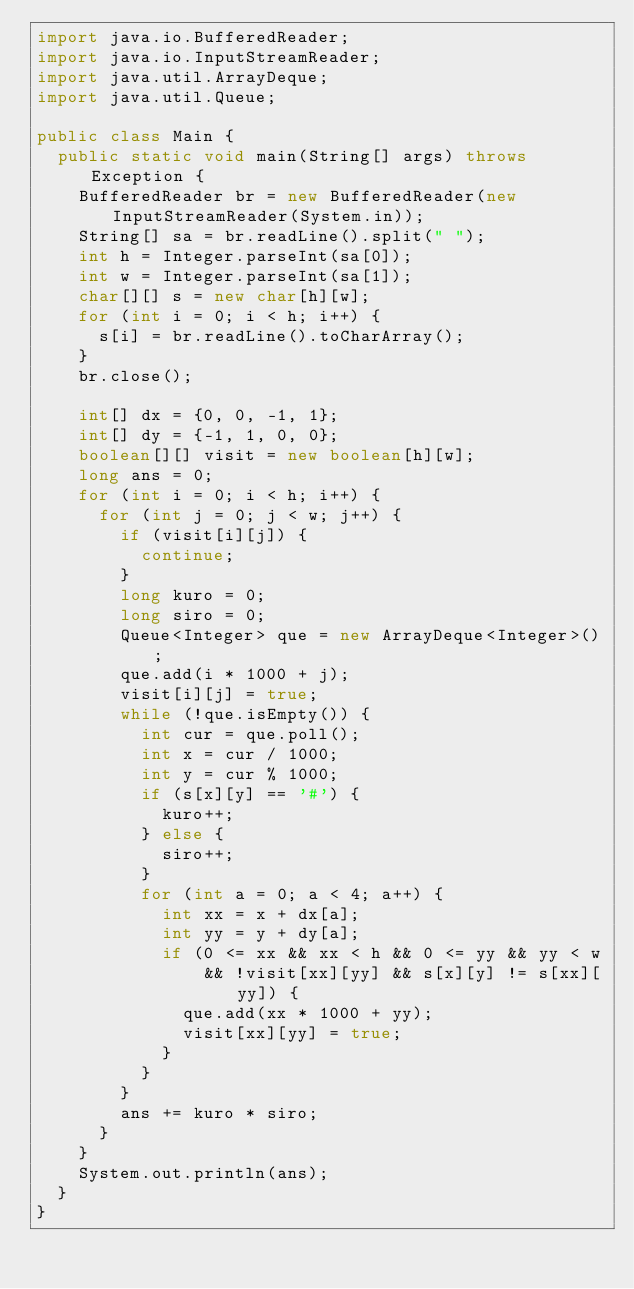<code> <loc_0><loc_0><loc_500><loc_500><_Java_>import java.io.BufferedReader;
import java.io.InputStreamReader;
import java.util.ArrayDeque;
import java.util.Queue;

public class Main {
	public static void main(String[] args) throws Exception {
		BufferedReader br = new BufferedReader(new InputStreamReader(System.in));
		String[] sa = br.readLine().split(" ");
		int h = Integer.parseInt(sa[0]);
		int w = Integer.parseInt(sa[1]);
		char[][] s = new char[h][w];
		for (int i = 0; i < h; i++) {
			s[i] = br.readLine().toCharArray();
		}
		br.close();

		int[] dx = {0, 0, -1, 1};
		int[] dy = {-1, 1, 0, 0};
		boolean[][] visit = new boolean[h][w];
		long ans = 0;
		for (int i = 0; i < h; i++) {
			for (int j = 0; j < w; j++) {
				if (visit[i][j]) {
					continue;
				}
				long kuro = 0;
				long siro = 0;
				Queue<Integer> que = new ArrayDeque<Integer>();
				que.add(i * 1000 + j);
				visit[i][j] = true;
				while (!que.isEmpty()) {
					int cur = que.poll();
					int x = cur / 1000;
					int y = cur % 1000;
					if (s[x][y] == '#') {
						kuro++;
					} else {
						siro++;
					}
					for (int a = 0; a < 4; a++) {
						int xx = x + dx[a];
						int yy = y + dy[a];
						if (0 <= xx && xx < h && 0 <= yy && yy < w
								&& !visit[xx][yy] && s[x][y] != s[xx][yy]) {
							que.add(xx * 1000 + yy);
							visit[xx][yy] = true;
						}
					}
				}
				ans += kuro * siro;
			}
		}
		System.out.println(ans);
	}
}
</code> 